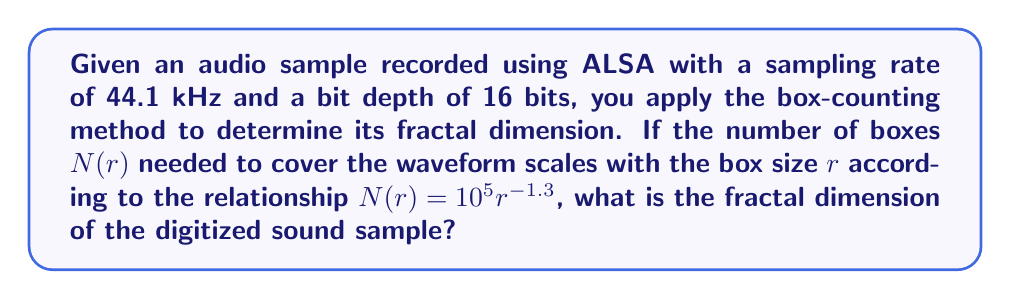Solve this math problem. To determine the fractal dimension using the box-counting method, we follow these steps:

1. Recall the box-counting dimension formula:
   $$D = \lim_{r \to 0} \frac{\log N(r)}{\log(1/r)}$$
   where $D$ is the fractal dimension, $N(r)$ is the number of boxes of size $r$ needed to cover the object.

2. We are given the relationship $N(r) = 10^5 r^{-1.3}$. Let's substitute this into the formula:
   $$D = \lim_{r \to 0} \frac{\log(10^5 r^{-1.3})}{\log(1/r)}$$

3. Using the properties of logarithms, we can simplify:
   $$D = \lim_{r \to 0} \frac{\log(10^5) + \log(r^{-1.3})}{\log(1/r)}$$
   $$D = \lim_{r \to 0} \frac{\log(10^5) - 1.3\log(r)}{\log(1/r)}$$

4. As $r \to 0$, $\log(10^5)$ becomes negligible compared to $\log(r)$, so we can ignore it:
   $$D = \lim_{r \to 0} \frac{-1.3\log(r)}{\log(1/r)}$$

5. Note that $\log(1/r) = -\log(r)$, so we have:
   $$D = \lim_{r \to 0} \frac{-1.3\log(r)}{-\log(r)}$$

6. The negative signs cancel out:
   $$D = \lim_{r \to 0} \frac{1.3\log(r)}{\log(r)} = 1.3$$

Therefore, the fractal dimension of the digitized sound sample is 1.3.
Answer: 1.3 